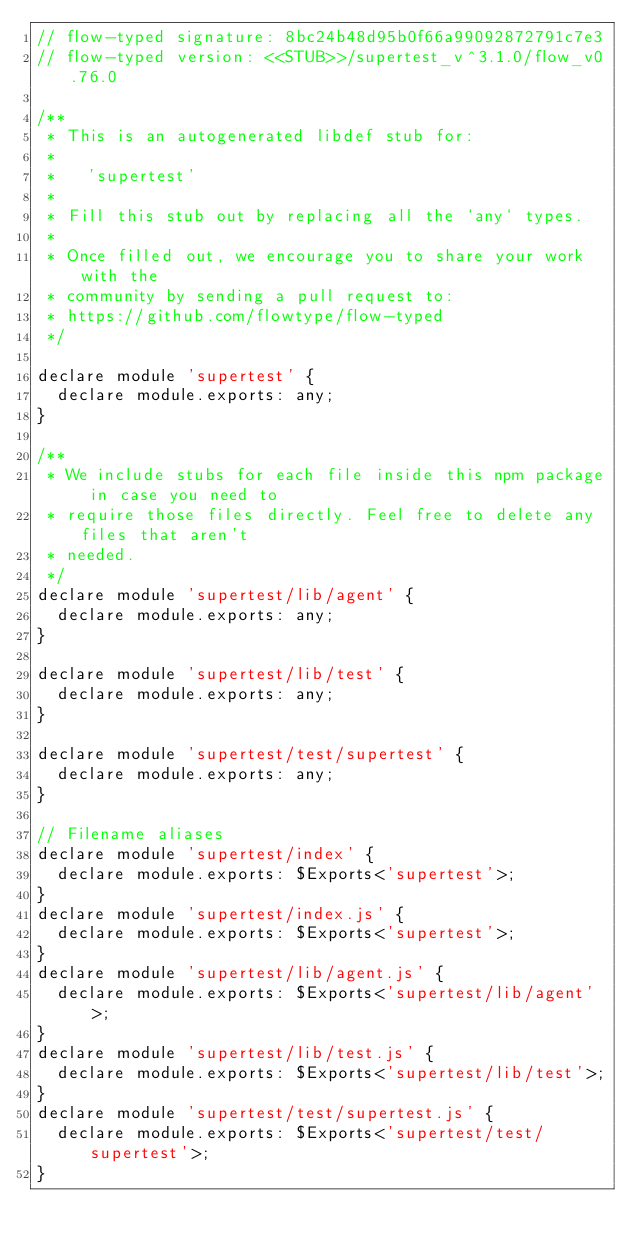Convert code to text. <code><loc_0><loc_0><loc_500><loc_500><_JavaScript_>// flow-typed signature: 8bc24b48d95b0f66a99092872791c7e3
// flow-typed version: <<STUB>>/supertest_v^3.1.0/flow_v0.76.0

/**
 * This is an autogenerated libdef stub for:
 *
 *   'supertest'
 *
 * Fill this stub out by replacing all the `any` types.
 *
 * Once filled out, we encourage you to share your work with the
 * community by sending a pull request to:
 * https://github.com/flowtype/flow-typed
 */

declare module 'supertest' {
  declare module.exports: any;
}

/**
 * We include stubs for each file inside this npm package in case you need to
 * require those files directly. Feel free to delete any files that aren't
 * needed.
 */
declare module 'supertest/lib/agent' {
  declare module.exports: any;
}

declare module 'supertest/lib/test' {
  declare module.exports: any;
}

declare module 'supertest/test/supertest' {
  declare module.exports: any;
}

// Filename aliases
declare module 'supertest/index' {
  declare module.exports: $Exports<'supertest'>;
}
declare module 'supertest/index.js' {
  declare module.exports: $Exports<'supertest'>;
}
declare module 'supertest/lib/agent.js' {
  declare module.exports: $Exports<'supertest/lib/agent'>;
}
declare module 'supertest/lib/test.js' {
  declare module.exports: $Exports<'supertest/lib/test'>;
}
declare module 'supertest/test/supertest.js' {
  declare module.exports: $Exports<'supertest/test/supertest'>;
}
</code> 